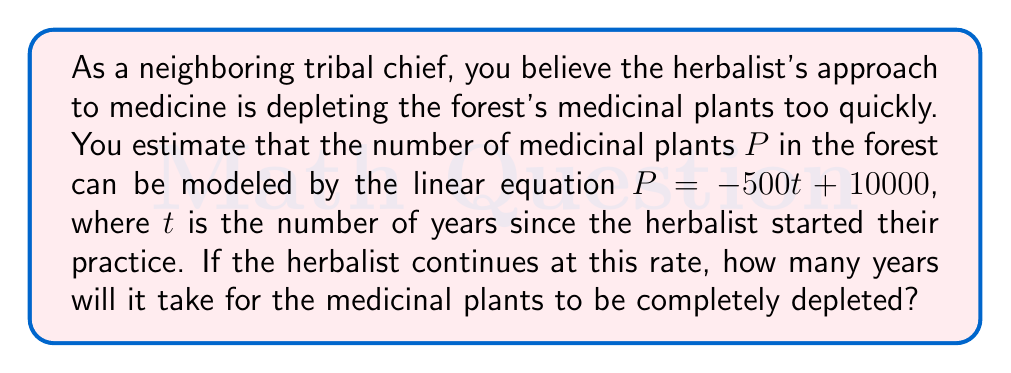What is the answer to this math problem? To solve this problem, we need to find the value of $t$ when $P = 0$. This represents the point at which all medicinal plants have been depleted.

Let's start with the given equation:
$$P = -500t + 10000$$

We want to find $t$ when $P = 0$:
$$0 = -500t + 10000$$

Now, let's solve for $t$:
1. Subtract 10000 from both sides:
   $$-10000 = -500t$$

2. Divide both sides by -500:
   $$20 = t$$

This means that after 20 years, the number of medicinal plants will reach zero if the depletion continues at the current rate.

To verify, we can plug $t = 20$ back into the original equation:
$$P = -500(20) + 10000 = -10000 + 10000 = 0$$

This confirms that after 20 years, the medicinal plants will be completely depleted.
Answer: It will take 20 years for the medicinal plants to be completely depleted. 